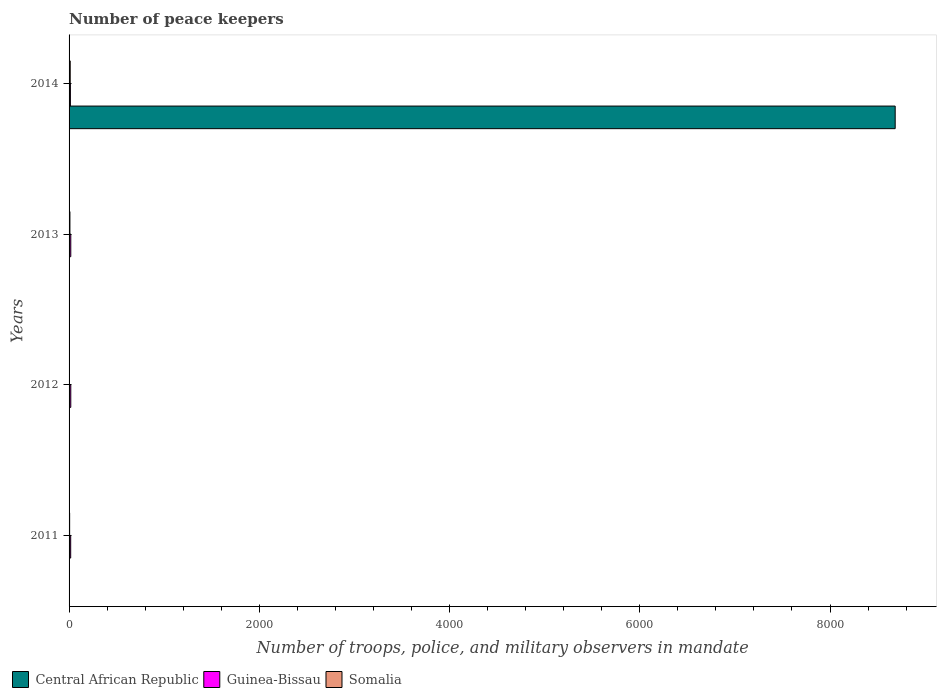How many groups of bars are there?
Offer a terse response. 4. Are the number of bars on each tick of the Y-axis equal?
Keep it short and to the point. Yes. How many bars are there on the 3rd tick from the top?
Ensure brevity in your answer.  3. What is the number of peace keepers in in Guinea-Bissau in 2011?
Ensure brevity in your answer.  17. What is the difference between the number of peace keepers in in Somalia in 2012 and that in 2013?
Your answer should be compact. -6. What is the difference between the number of peace keepers in in Central African Republic in 2014 and the number of peace keepers in in Somalia in 2013?
Provide a short and direct response. 8676. What is the average number of peace keepers in in Somalia per year?
Provide a succinct answer. 7.5. In how many years, is the number of peace keepers in in Guinea-Bissau greater than 7200 ?
Your response must be concise. 0. What is the ratio of the number of peace keepers in in Somalia in 2012 to that in 2014?
Your response must be concise. 0.25. Is the number of peace keepers in in Guinea-Bissau in 2011 less than that in 2014?
Ensure brevity in your answer.  No. Is the difference between the number of peace keepers in in Guinea-Bissau in 2011 and 2012 greater than the difference between the number of peace keepers in in Somalia in 2011 and 2012?
Ensure brevity in your answer.  No. What is the difference between the highest and the second highest number of peace keepers in in Central African Republic?
Your answer should be compact. 8681. What is the difference between the highest and the lowest number of peace keepers in in Guinea-Bissau?
Ensure brevity in your answer.  4. What does the 2nd bar from the top in 2014 represents?
Keep it short and to the point. Guinea-Bissau. What does the 3rd bar from the bottom in 2011 represents?
Offer a terse response. Somalia. What is the difference between two consecutive major ticks on the X-axis?
Your answer should be compact. 2000. Are the values on the major ticks of X-axis written in scientific E-notation?
Give a very brief answer. No. Does the graph contain any zero values?
Make the answer very short. No. Where does the legend appear in the graph?
Your response must be concise. Bottom left. How many legend labels are there?
Offer a terse response. 3. How are the legend labels stacked?
Ensure brevity in your answer.  Horizontal. What is the title of the graph?
Ensure brevity in your answer.  Number of peace keepers. What is the label or title of the X-axis?
Make the answer very short. Number of troops, police, and military observers in mandate. What is the label or title of the Y-axis?
Keep it short and to the point. Years. What is the Number of troops, police, and military observers in mandate of Central African Republic in 2011?
Ensure brevity in your answer.  4. What is the Number of troops, police, and military observers in mandate of Central African Republic in 2012?
Give a very brief answer. 4. What is the Number of troops, police, and military observers in mandate in Guinea-Bissau in 2012?
Offer a very short reply. 18. What is the Number of troops, police, and military observers in mandate in Central African Republic in 2013?
Your answer should be very brief. 4. What is the Number of troops, police, and military observers in mandate of Central African Republic in 2014?
Make the answer very short. 8685. What is the Number of troops, police, and military observers in mandate in Guinea-Bissau in 2014?
Give a very brief answer. 14. What is the Number of troops, police, and military observers in mandate of Somalia in 2014?
Offer a terse response. 12. Across all years, what is the maximum Number of troops, police, and military observers in mandate of Central African Republic?
Offer a very short reply. 8685. Across all years, what is the maximum Number of troops, police, and military observers in mandate in Somalia?
Give a very brief answer. 12. Across all years, what is the minimum Number of troops, police, and military observers in mandate in Somalia?
Keep it short and to the point. 3. What is the total Number of troops, police, and military observers in mandate in Central African Republic in the graph?
Offer a terse response. 8697. What is the total Number of troops, police, and military observers in mandate in Somalia in the graph?
Provide a short and direct response. 30. What is the difference between the Number of troops, police, and military observers in mandate in Central African Republic in 2011 and that in 2012?
Keep it short and to the point. 0. What is the difference between the Number of troops, police, and military observers in mandate of Guinea-Bissau in 2011 and that in 2012?
Your answer should be compact. -1. What is the difference between the Number of troops, police, and military observers in mandate of Somalia in 2011 and that in 2012?
Give a very brief answer. 3. What is the difference between the Number of troops, police, and military observers in mandate in Somalia in 2011 and that in 2013?
Provide a short and direct response. -3. What is the difference between the Number of troops, police, and military observers in mandate of Central African Republic in 2011 and that in 2014?
Give a very brief answer. -8681. What is the difference between the Number of troops, police, and military observers in mandate in Somalia in 2011 and that in 2014?
Ensure brevity in your answer.  -6. What is the difference between the Number of troops, police, and military observers in mandate of Central African Republic in 2012 and that in 2013?
Your answer should be very brief. 0. What is the difference between the Number of troops, police, and military observers in mandate of Central African Republic in 2012 and that in 2014?
Provide a short and direct response. -8681. What is the difference between the Number of troops, police, and military observers in mandate in Central African Republic in 2013 and that in 2014?
Your response must be concise. -8681. What is the difference between the Number of troops, police, and military observers in mandate of Guinea-Bissau in 2013 and that in 2014?
Offer a terse response. 4. What is the difference between the Number of troops, police, and military observers in mandate in Central African Republic in 2011 and the Number of troops, police, and military observers in mandate in Guinea-Bissau in 2012?
Provide a short and direct response. -14. What is the difference between the Number of troops, police, and military observers in mandate of Central African Republic in 2011 and the Number of troops, police, and military observers in mandate of Guinea-Bissau in 2013?
Offer a terse response. -14. What is the difference between the Number of troops, police, and military observers in mandate of Central African Republic in 2011 and the Number of troops, police, and military observers in mandate of Somalia in 2013?
Ensure brevity in your answer.  -5. What is the difference between the Number of troops, police, and military observers in mandate of Central African Republic in 2013 and the Number of troops, police, and military observers in mandate of Guinea-Bissau in 2014?
Provide a succinct answer. -10. What is the difference between the Number of troops, police, and military observers in mandate in Guinea-Bissau in 2013 and the Number of troops, police, and military observers in mandate in Somalia in 2014?
Make the answer very short. 6. What is the average Number of troops, police, and military observers in mandate in Central African Republic per year?
Your response must be concise. 2174.25. What is the average Number of troops, police, and military observers in mandate in Guinea-Bissau per year?
Ensure brevity in your answer.  16.75. What is the average Number of troops, police, and military observers in mandate in Somalia per year?
Your answer should be very brief. 7.5. In the year 2011, what is the difference between the Number of troops, police, and military observers in mandate of Central African Republic and Number of troops, police, and military observers in mandate of Guinea-Bissau?
Provide a succinct answer. -13. In the year 2011, what is the difference between the Number of troops, police, and military observers in mandate of Guinea-Bissau and Number of troops, police, and military observers in mandate of Somalia?
Ensure brevity in your answer.  11. In the year 2012, what is the difference between the Number of troops, police, and military observers in mandate in Central African Republic and Number of troops, police, and military observers in mandate in Guinea-Bissau?
Give a very brief answer. -14. In the year 2012, what is the difference between the Number of troops, police, and military observers in mandate in Central African Republic and Number of troops, police, and military observers in mandate in Somalia?
Offer a very short reply. 1. In the year 2013, what is the difference between the Number of troops, police, and military observers in mandate of Central African Republic and Number of troops, police, and military observers in mandate of Guinea-Bissau?
Your response must be concise. -14. In the year 2013, what is the difference between the Number of troops, police, and military observers in mandate in Guinea-Bissau and Number of troops, police, and military observers in mandate in Somalia?
Give a very brief answer. 9. In the year 2014, what is the difference between the Number of troops, police, and military observers in mandate in Central African Republic and Number of troops, police, and military observers in mandate in Guinea-Bissau?
Offer a terse response. 8671. In the year 2014, what is the difference between the Number of troops, police, and military observers in mandate of Central African Republic and Number of troops, police, and military observers in mandate of Somalia?
Make the answer very short. 8673. What is the ratio of the Number of troops, police, and military observers in mandate of Central African Republic in 2011 to that in 2012?
Make the answer very short. 1. What is the ratio of the Number of troops, police, and military observers in mandate in Guinea-Bissau in 2011 to that in 2012?
Keep it short and to the point. 0.94. What is the ratio of the Number of troops, police, and military observers in mandate of Central African Republic in 2011 to that in 2013?
Provide a short and direct response. 1. What is the ratio of the Number of troops, police, and military observers in mandate in Guinea-Bissau in 2011 to that in 2013?
Make the answer very short. 0.94. What is the ratio of the Number of troops, police, and military observers in mandate of Somalia in 2011 to that in 2013?
Your answer should be very brief. 0.67. What is the ratio of the Number of troops, police, and military observers in mandate of Guinea-Bissau in 2011 to that in 2014?
Your answer should be very brief. 1.21. What is the ratio of the Number of troops, police, and military observers in mandate of Central African Republic in 2012 to that in 2013?
Provide a short and direct response. 1. What is the ratio of the Number of troops, police, and military observers in mandate of Somalia in 2012 to that in 2013?
Give a very brief answer. 0.33. What is the ratio of the Number of troops, police, and military observers in mandate in Central African Republic in 2012 to that in 2014?
Your response must be concise. 0. What is the ratio of the Number of troops, police, and military observers in mandate in Central African Republic in 2013 to that in 2014?
Offer a terse response. 0. What is the difference between the highest and the second highest Number of troops, police, and military observers in mandate in Central African Republic?
Provide a short and direct response. 8681. What is the difference between the highest and the second highest Number of troops, police, and military observers in mandate of Somalia?
Your answer should be compact. 3. What is the difference between the highest and the lowest Number of troops, police, and military observers in mandate in Central African Republic?
Provide a short and direct response. 8681. What is the difference between the highest and the lowest Number of troops, police, and military observers in mandate in Somalia?
Your response must be concise. 9. 